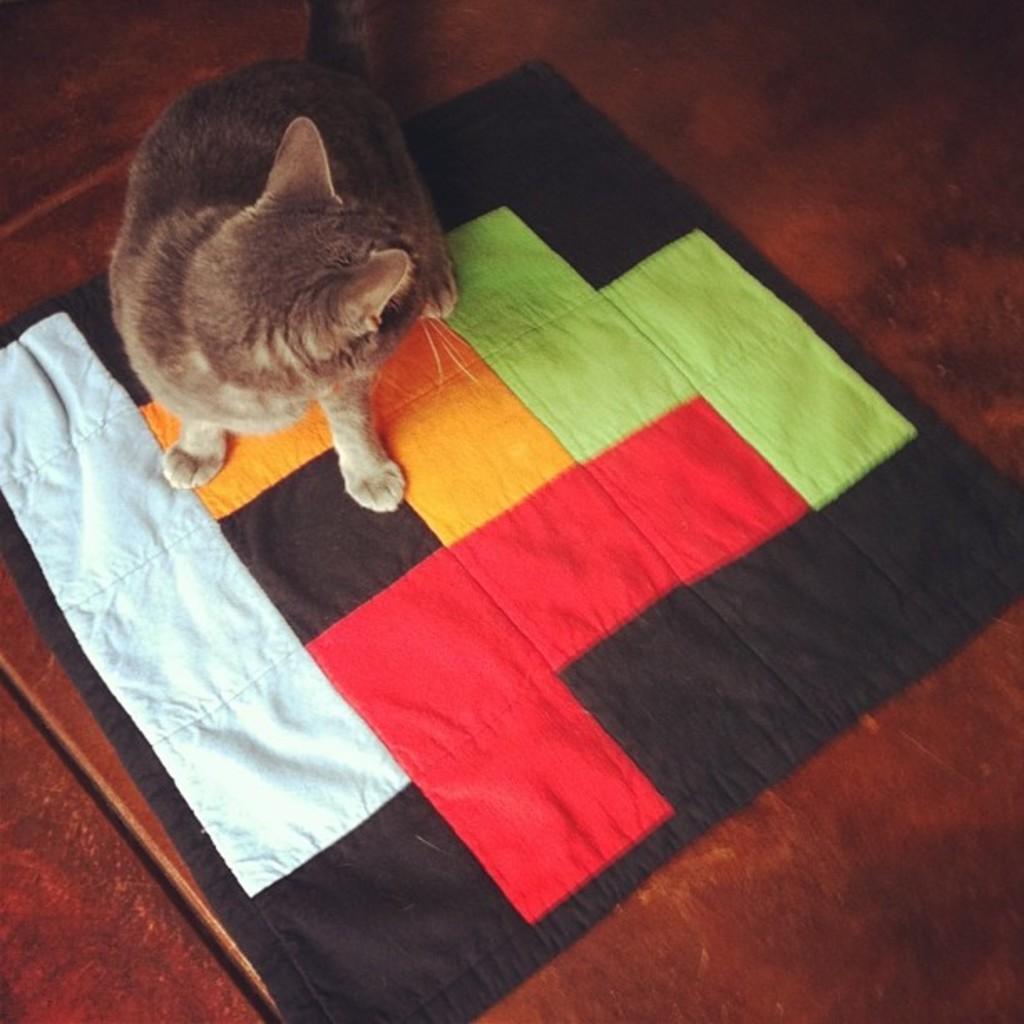Please provide a concise description of this image. In this picture, we see a brown cat. It is on the carpet, which is in white, red, yellow green and black color. At the bottom, we see a table or the floor in brown color. 